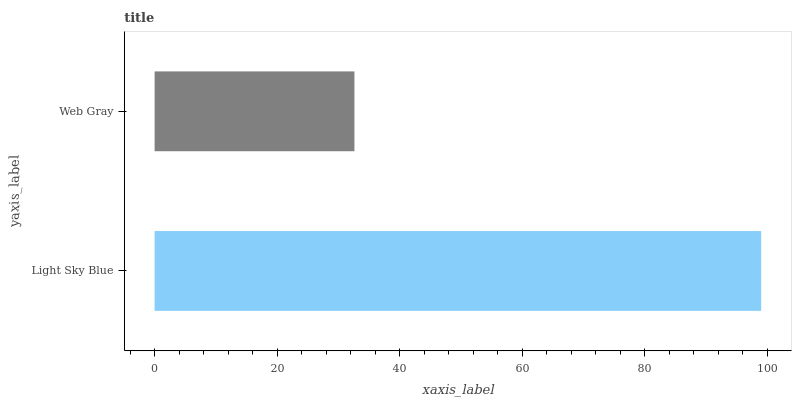Is Web Gray the minimum?
Answer yes or no. Yes. Is Light Sky Blue the maximum?
Answer yes or no. Yes. Is Web Gray the maximum?
Answer yes or no. No. Is Light Sky Blue greater than Web Gray?
Answer yes or no. Yes. Is Web Gray less than Light Sky Blue?
Answer yes or no. Yes. Is Web Gray greater than Light Sky Blue?
Answer yes or no. No. Is Light Sky Blue less than Web Gray?
Answer yes or no. No. Is Light Sky Blue the high median?
Answer yes or no. Yes. Is Web Gray the low median?
Answer yes or no. Yes. Is Web Gray the high median?
Answer yes or no. No. Is Light Sky Blue the low median?
Answer yes or no. No. 